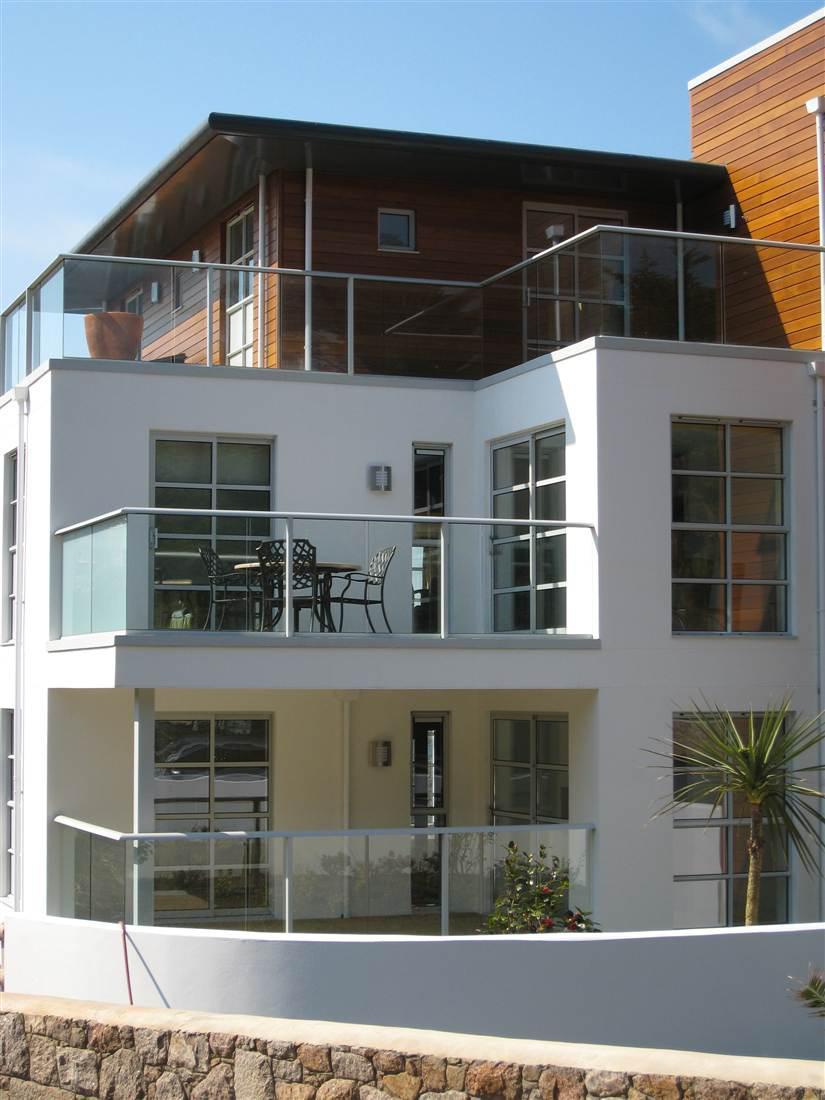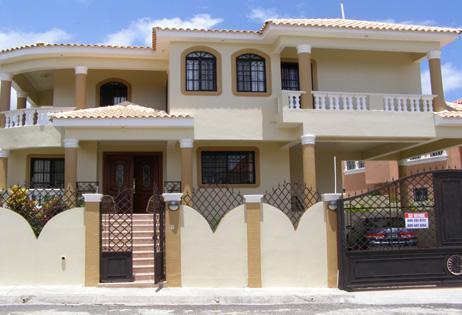The first image is the image on the left, the second image is the image on the right. Considering the images on both sides, is "The left and right image contains the same number of stories on a single home." valid? Answer yes or no. No. 